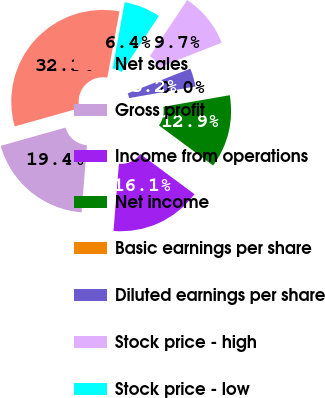Convert chart. <chart><loc_0><loc_0><loc_500><loc_500><pie_chart><fcel>Net sales<fcel>Gross profit<fcel>Income from operations<fcel>Net income<fcel>Basic earnings per share<fcel>Diluted earnings per share<fcel>Stock price - high<fcel>Stock price - low<nl><fcel>32.26%<fcel>19.35%<fcel>16.13%<fcel>12.9%<fcel>0.0%<fcel>3.23%<fcel>9.68%<fcel>6.45%<nl></chart> 